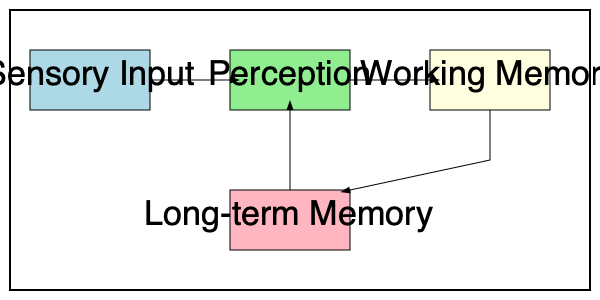In the flowchart representing the stages of information processing in the human brain, which stage directly interacts with both Working Memory and Perception? To answer this question, we need to analyze the flowchart and understand the connections between different stages of information processing:

1. The flowchart shows four main stages: Sensory Input, Perception, Working Memory, and Long-term Memory.

2. Let's examine the connections:
   a) Sensory Input connects to Perception
   b) Perception connects to Working Memory
   c) Working Memory has a bidirectional connection with Long-term Memory
   d) Long-term Memory has a connection back to Perception

3. We're looking for a stage that directly interacts with both Working Memory and Perception.

4. Long-term Memory is the only stage that meets this criteria:
   - It has an arrow going to Perception, indicating it interacts with Perception.
   - It has a bidirectional arrow with Working Memory, indicating it interacts with Working Memory.

5. No other stage in the flowchart has direct connections to both Working Memory and Perception.

Therefore, the stage that directly interacts with both Working Memory and Perception is Long-term Memory.
Answer: Long-term Memory 